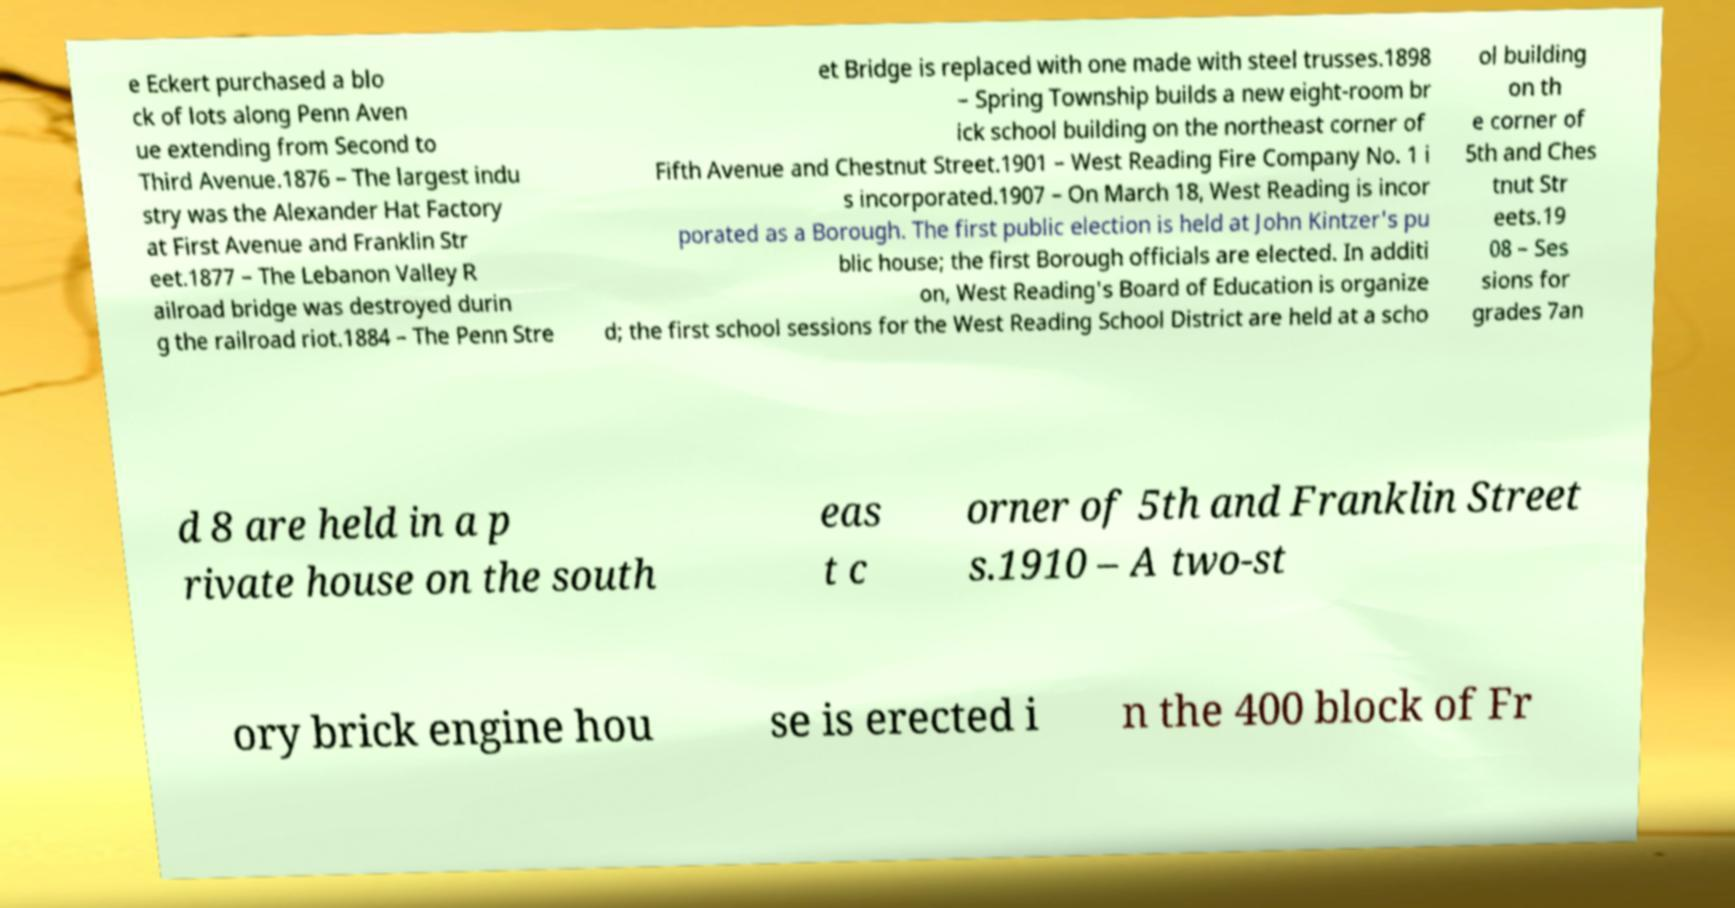Please identify and transcribe the text found in this image. e Eckert purchased a blo ck of lots along Penn Aven ue extending from Second to Third Avenue.1876 – The largest indu stry was the Alexander Hat Factory at First Avenue and Franklin Str eet.1877 – The Lebanon Valley R ailroad bridge was destroyed durin g the railroad riot.1884 – The Penn Stre et Bridge is replaced with one made with steel trusses.1898 – Spring Township builds a new eight-room br ick school building on the northeast corner of Fifth Avenue and Chestnut Street.1901 – West Reading Fire Company No. 1 i s incorporated.1907 – On March 18, West Reading is incor porated as a Borough. The first public election is held at John Kintzer's pu blic house; the first Borough officials are elected. In additi on, West Reading's Board of Education is organize d; the first school sessions for the West Reading School District are held at a scho ol building on th e corner of 5th and Ches tnut Str eets.19 08 – Ses sions for grades 7an d 8 are held in a p rivate house on the south eas t c orner of 5th and Franklin Street s.1910 – A two-st ory brick engine hou se is erected i n the 400 block of Fr 